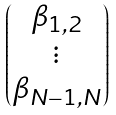<formula> <loc_0><loc_0><loc_500><loc_500>\begin{pmatrix} \beta _ { 1 , 2 } \\ \vdots \\ \beta _ { N - 1 , N } \end{pmatrix}</formula> 